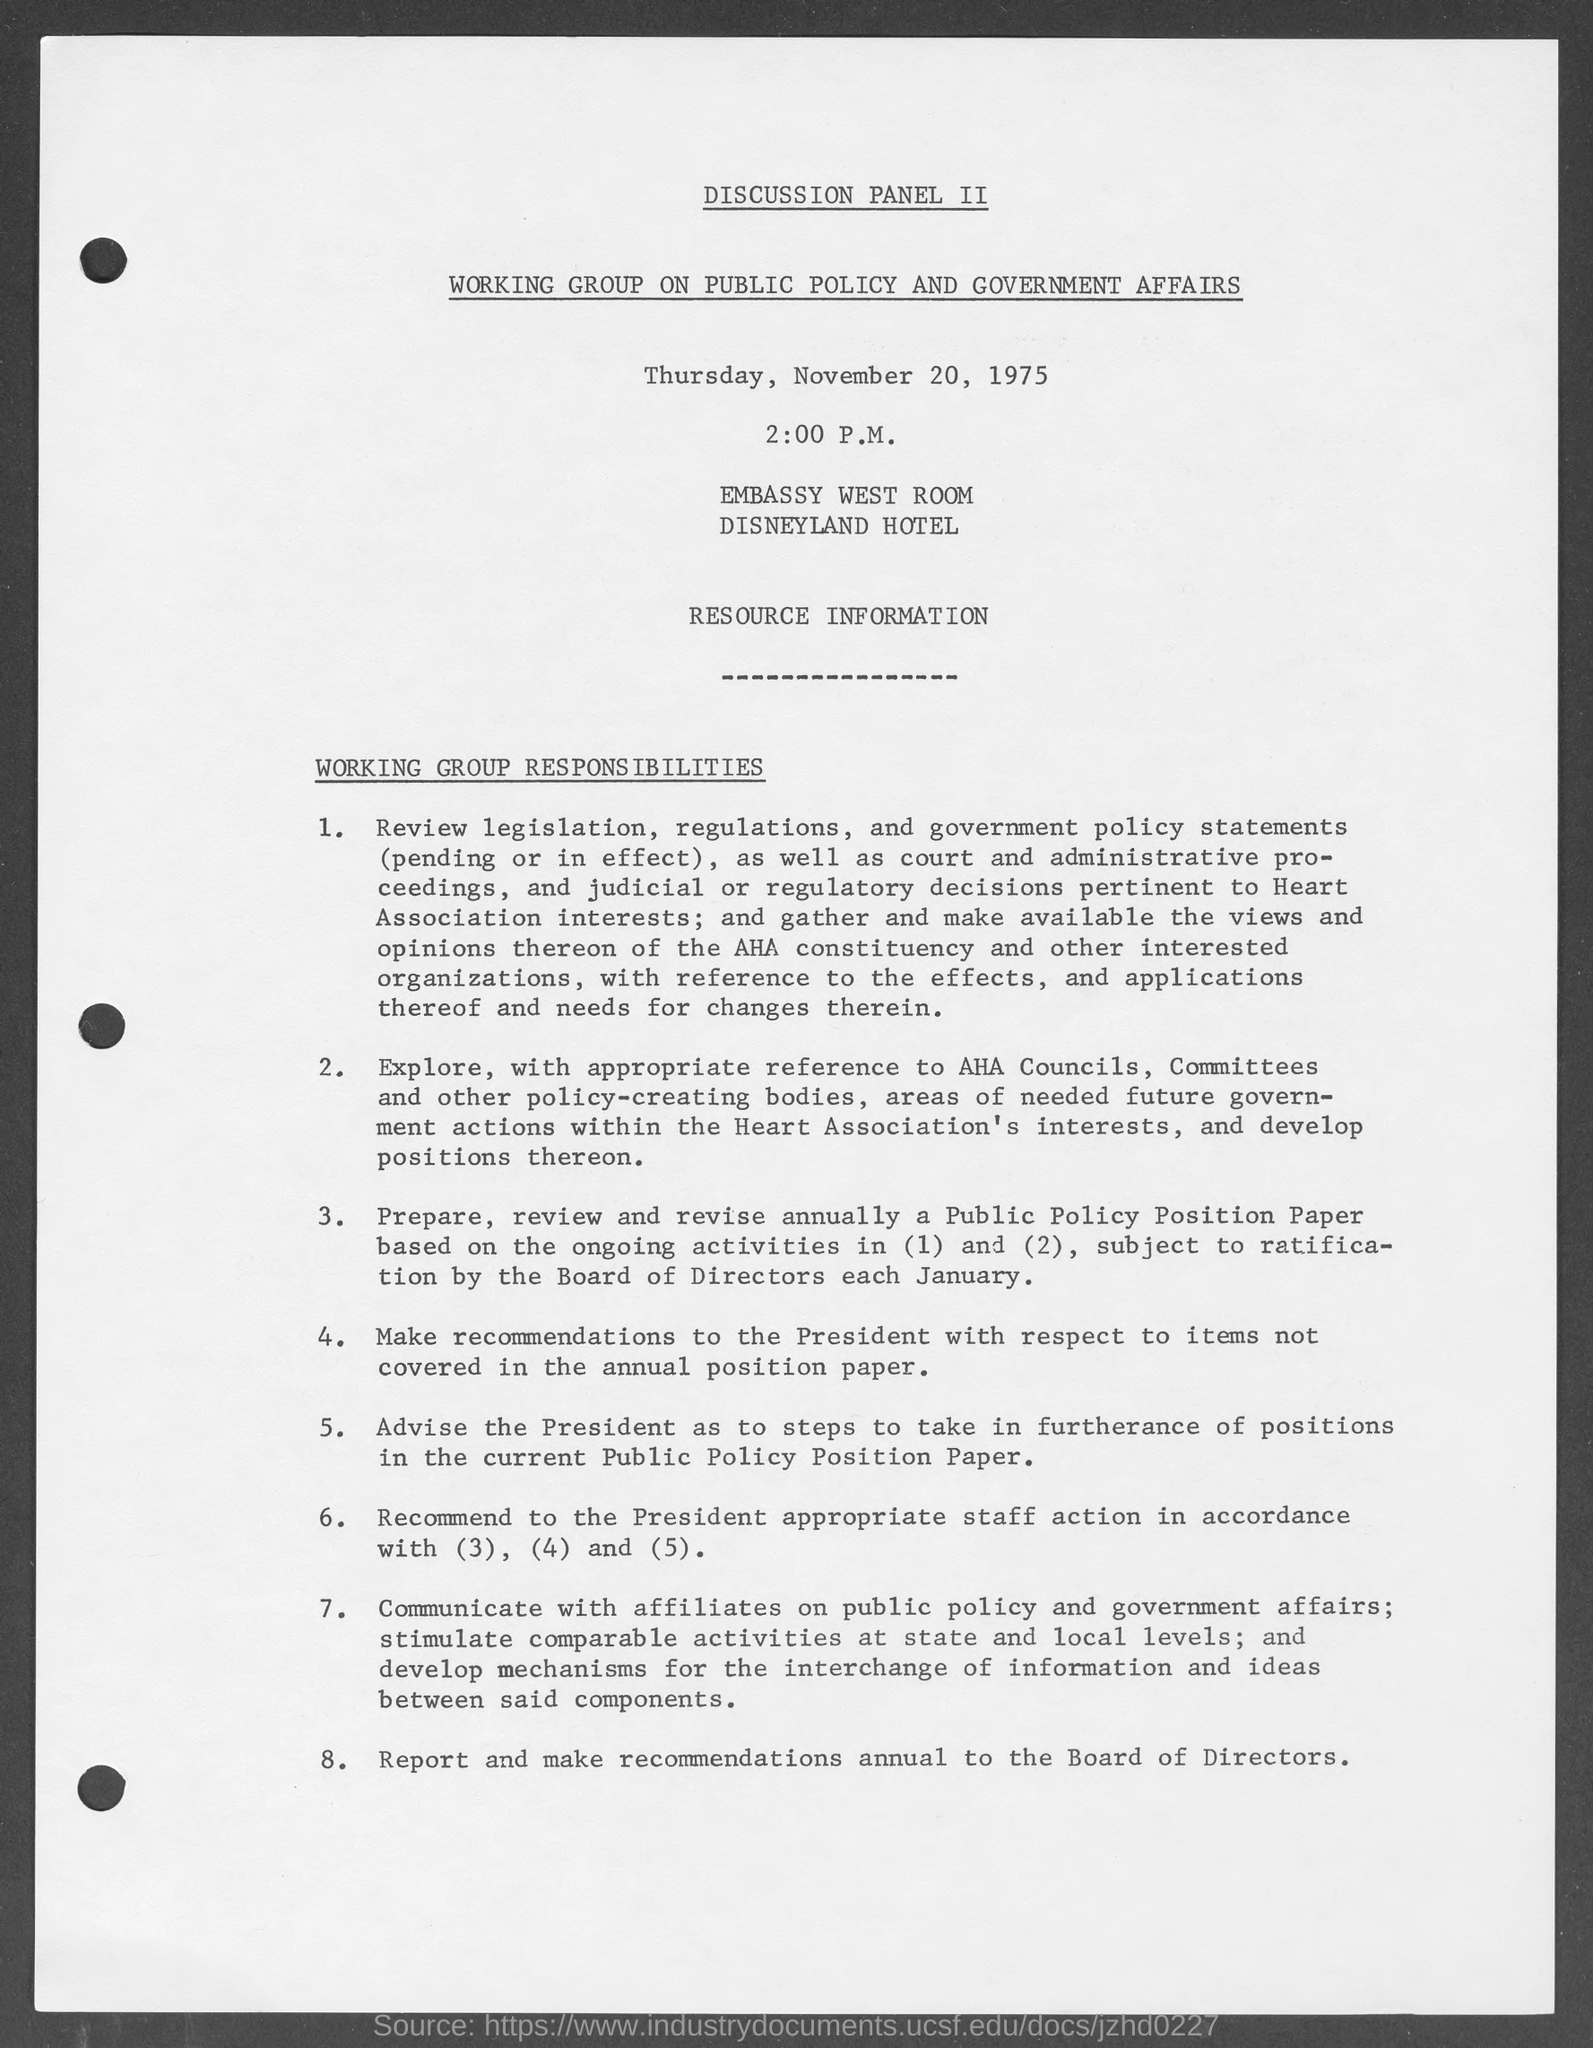What is the date mentioned in the given page ?
Your answer should be very brief. November 20, 1975. What is the name of the hotel mentioned in the given page ?
Your answer should be very brief. Disneyland hotel. In which room the discussion was happening ?
Offer a terse response. Embassy west room. On which topic the discussion panel ii was working on ?
Your answer should be very brief. Working group on public policy and government affairs. 